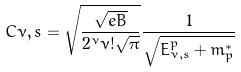<formula> <loc_0><loc_0><loc_500><loc_500>C { \nu , s } = \sqrt { \frac { \sqrt { e B } } { 2 ^ { \nu } \nu ! \sqrt { \pi } } } \frac { 1 } { \sqrt { E _ { \nu , s } ^ { p } + m _ { p } ^ { * } } }</formula> 